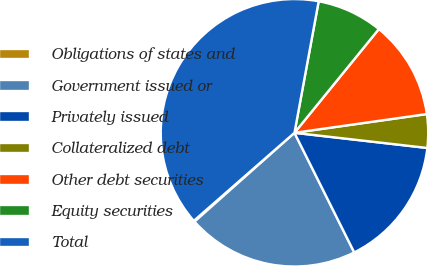Convert chart. <chart><loc_0><loc_0><loc_500><loc_500><pie_chart><fcel>Obligations of states and<fcel>Government issued or<fcel>Privately issued<fcel>Collateralized debt<fcel>Other debt securities<fcel>Equity securities<fcel>Total<nl><fcel>0.13%<fcel>20.81%<fcel>15.81%<fcel>4.05%<fcel>11.89%<fcel>7.97%<fcel>39.33%<nl></chart> 